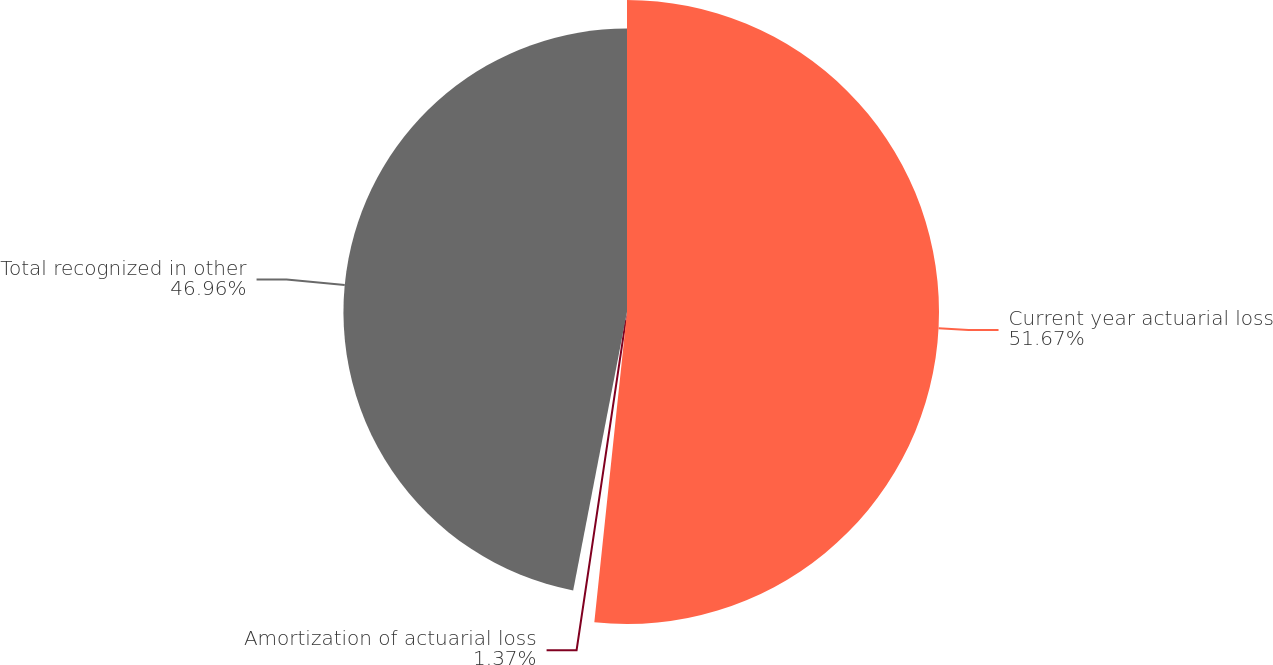Convert chart to OTSL. <chart><loc_0><loc_0><loc_500><loc_500><pie_chart><fcel>Current year actuarial loss<fcel>Amortization of actuarial loss<fcel>Total recognized in other<nl><fcel>51.67%<fcel>1.37%<fcel>46.96%<nl></chart> 